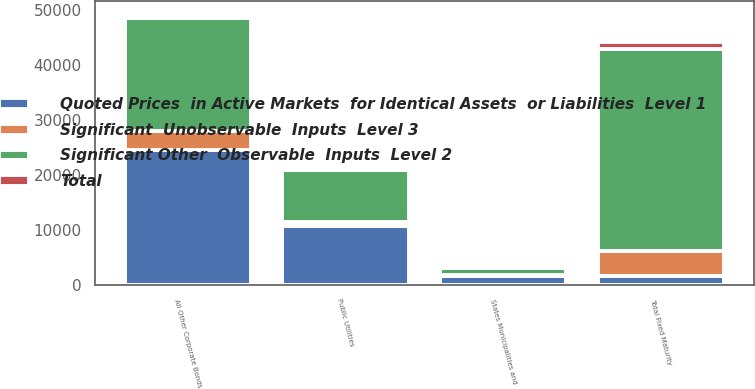Convert chart to OTSL. <chart><loc_0><loc_0><loc_500><loc_500><stacked_bar_chart><ecel><fcel>States Municipalities and<fcel>Public Utilities<fcel>All Other Corporate Bonds<fcel>Total Fixed Maturity<nl><fcel>Significant  Unobservable  Inputs  Level 3<fcel>107.3<fcel>718<fcel>3469.5<fcel>4621.4<nl><fcel>Significant Other  Observable  Inputs  Level 2<fcel>1416.2<fcel>9576.4<fcel>20415.1<fcel>36723.9<nl><fcel>Total<fcel>68.1<fcel>338.9<fcel>665.5<fcel>1141.4<nl><fcel>Quoted Prices  in Active Markets  for Identical Assets  or Liabilities  Level 1<fcel>1591.6<fcel>10633.3<fcel>24550.1<fcel>1591.6<nl></chart> 